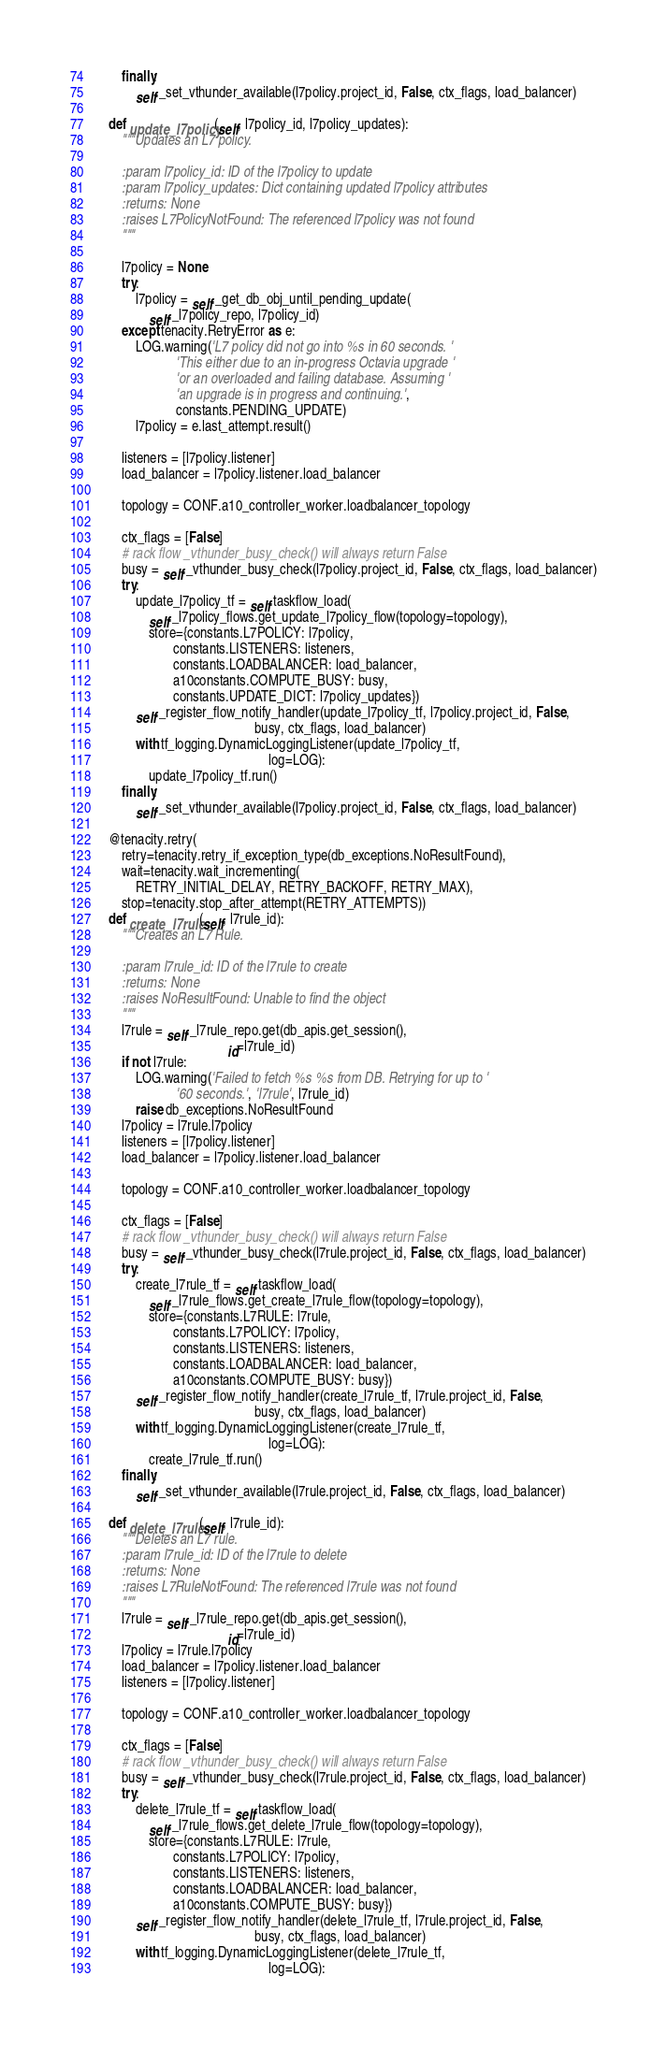Convert code to text. <code><loc_0><loc_0><loc_500><loc_500><_Python_>        finally:
            self._set_vthunder_available(l7policy.project_id, False, ctx_flags, load_balancer)

    def update_l7policy(self, l7policy_id, l7policy_updates):
        """Updates an L7 policy.

        :param l7policy_id: ID of the l7policy to update
        :param l7policy_updates: Dict containing updated l7policy attributes
        :returns: None
        :raises L7PolicyNotFound: The referenced l7policy was not found
        """

        l7policy = None
        try:
            l7policy = self._get_db_obj_until_pending_update(
                self._l7policy_repo, l7policy_id)
        except tenacity.RetryError as e:
            LOG.warning('L7 policy did not go into %s in 60 seconds. '
                        'This either due to an in-progress Octavia upgrade '
                        'or an overloaded and failing database. Assuming '
                        'an upgrade is in progress and continuing.',
                        constants.PENDING_UPDATE)
            l7policy = e.last_attempt.result()

        listeners = [l7policy.listener]
        load_balancer = l7policy.listener.load_balancer

        topology = CONF.a10_controller_worker.loadbalancer_topology

        ctx_flags = [False]
        # rack flow _vthunder_busy_check() will always return False
        busy = self._vthunder_busy_check(l7policy.project_id, False, ctx_flags, load_balancer)
        try:
            update_l7policy_tf = self.taskflow_load(
                self._l7policy_flows.get_update_l7policy_flow(topology=topology),
                store={constants.L7POLICY: l7policy,
                       constants.LISTENERS: listeners,
                       constants.LOADBALANCER: load_balancer,
                       a10constants.COMPUTE_BUSY: busy,
                       constants.UPDATE_DICT: l7policy_updates})
            self._register_flow_notify_handler(update_l7policy_tf, l7policy.project_id, False,
                                               busy, ctx_flags, load_balancer)
            with tf_logging.DynamicLoggingListener(update_l7policy_tf,
                                                   log=LOG):
                update_l7policy_tf.run()
        finally:
            self._set_vthunder_available(l7policy.project_id, False, ctx_flags, load_balancer)

    @tenacity.retry(
        retry=tenacity.retry_if_exception_type(db_exceptions.NoResultFound),
        wait=tenacity.wait_incrementing(
            RETRY_INITIAL_DELAY, RETRY_BACKOFF, RETRY_MAX),
        stop=tenacity.stop_after_attempt(RETRY_ATTEMPTS))
    def create_l7rule(self, l7rule_id):
        """Creates an L7 Rule.

        :param l7rule_id: ID of the l7rule to create
        :returns: None
        :raises NoResultFound: Unable to find the object
        """
        l7rule = self._l7rule_repo.get(db_apis.get_session(),
                                       id=l7rule_id)
        if not l7rule:
            LOG.warning('Failed to fetch %s %s from DB. Retrying for up to '
                        '60 seconds.', 'l7rule', l7rule_id)
            raise db_exceptions.NoResultFound
        l7policy = l7rule.l7policy
        listeners = [l7policy.listener]
        load_balancer = l7policy.listener.load_balancer

        topology = CONF.a10_controller_worker.loadbalancer_topology

        ctx_flags = [False]
        # rack flow _vthunder_busy_check() will always return False
        busy = self._vthunder_busy_check(l7rule.project_id, False, ctx_flags, load_balancer)
        try:
            create_l7rule_tf = self.taskflow_load(
                self._l7rule_flows.get_create_l7rule_flow(topology=topology),
                store={constants.L7RULE: l7rule,
                       constants.L7POLICY: l7policy,
                       constants.LISTENERS: listeners,
                       constants.LOADBALANCER: load_balancer,
                       a10constants.COMPUTE_BUSY: busy})
            self._register_flow_notify_handler(create_l7rule_tf, l7rule.project_id, False,
                                               busy, ctx_flags, load_balancer)
            with tf_logging.DynamicLoggingListener(create_l7rule_tf,
                                                   log=LOG):
                create_l7rule_tf.run()
        finally:
            self._set_vthunder_available(l7rule.project_id, False, ctx_flags, load_balancer)

    def delete_l7rule(self, l7rule_id):
        """Deletes an L7 rule.
        :param l7rule_id: ID of the l7rule to delete
        :returns: None
        :raises L7RuleNotFound: The referenced l7rule was not found
        """
        l7rule = self._l7rule_repo.get(db_apis.get_session(),
                                       id=l7rule_id)
        l7policy = l7rule.l7policy
        load_balancer = l7policy.listener.load_balancer
        listeners = [l7policy.listener]

        topology = CONF.a10_controller_worker.loadbalancer_topology

        ctx_flags = [False]
        # rack flow _vthunder_busy_check() will always return False
        busy = self._vthunder_busy_check(l7rule.project_id, False, ctx_flags, load_balancer)
        try:
            delete_l7rule_tf = self.taskflow_load(
                self._l7rule_flows.get_delete_l7rule_flow(topology=topology),
                store={constants.L7RULE: l7rule,
                       constants.L7POLICY: l7policy,
                       constants.LISTENERS: listeners,
                       constants.LOADBALANCER: load_balancer,
                       a10constants.COMPUTE_BUSY: busy})
            self._register_flow_notify_handler(delete_l7rule_tf, l7rule.project_id, False,
                                               busy, ctx_flags, load_balancer)
            with tf_logging.DynamicLoggingListener(delete_l7rule_tf,
                                                   log=LOG):</code> 